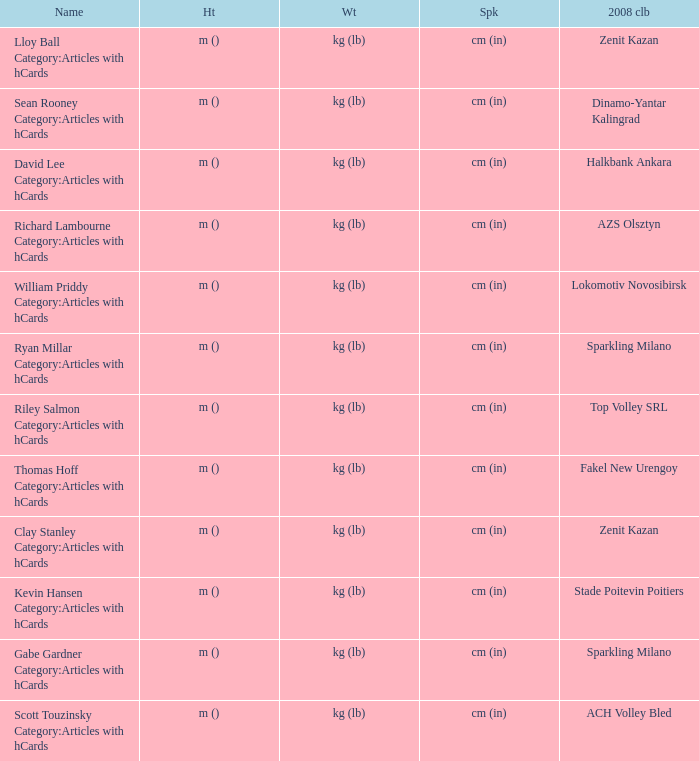What shows for height for the 2008 club of Stade Poitevin Poitiers? M (). 